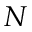<formula> <loc_0><loc_0><loc_500><loc_500>N</formula> 